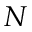<formula> <loc_0><loc_0><loc_500><loc_500>N</formula> 